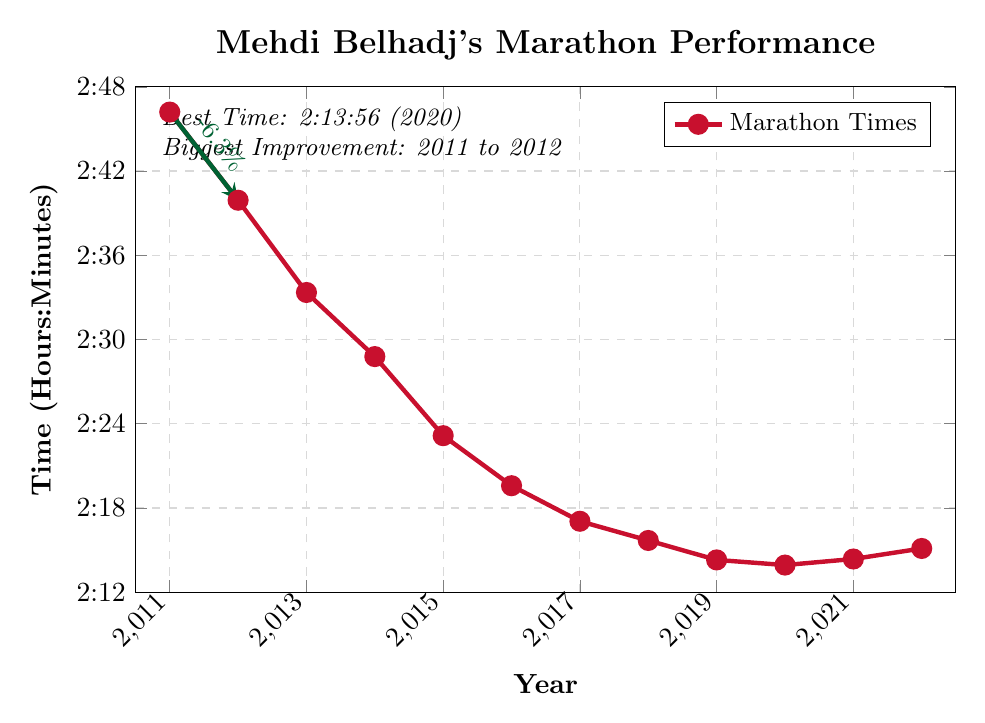What is the best marathon time that Mehdi Belhadj achieved? The best marathon time is highlighted in the figure at 2:13:56, achieved in the year 2020.
Answer: 2:13:56 In which year did Mehdi show the biggest improvement in his marathon time? According to the figure, the biggest improvement is indicated between 2011 and 2012, with a time reduction of -6.3%.
Answer: 2011 to 2012 How did Mehdi's marathon time change from 2020 to 2021? The time increased from 2:13:56 in 2020 to 2:14:22 in 2021, showing a slight decline in performance.
Answer: Increased In which year did Mehdi's marathon time reach approximately 2:30 hours? The 2014 Rotterdam Marathon has a time of approximately 2:28:47, which is closest to 2:30 hours.
Answer: 2014 Compare Mehdi's marathon time in 2015 and 2016. Which year was faster? By looking at the figure, in 2015, the time was 2:23:09, and in 2016, it improved to 2:19:35. Thus, 2016 was faster.
Answer: 2016 What is the average marathon time over his career from 2011 to 2022? To find the average, sum all the times given in hours and divide by the number of years: (2.77 + 2.6653 + 2.5558 + 2.4797 + 2.3858 + 2.3264 + 2.2842 + 2.2614 + 2.2383 + 2.2322 + 2.2394 + 2.2519) / 12 = 2.4433.
Answer: 2:26:36 Which marathon has the smallest improvement compared to the previous year? From the figure, the smallest improvement is from 2020 to 2021, where the time increased slightly rather than improved.
Answer: 2020 to 2021 What is the peak performance year for Mehdi Belhadj based on his marathon times? The peak performance is indicated as the best time on the plot, which occurred in 2020 with a time of 2:13:56.
Answer: 2020 In which two consecutive years did Mehdi Belhadj experience a decline in performance? By examining the plot, he experienced a decline in performance from 2020 to 2021 and again from 2021 to 2022.
Answer: 2020 to 2021 and 2021 to 2022 How consistent was Mehdi’s performance between 2018 and 2022? Scrutinizing the figure, Mehdi’s times were relatively stable between 2018 (2:15:41) and 2022 (2:15:07), with minor variations each year.
Answer: Relatively consistent 